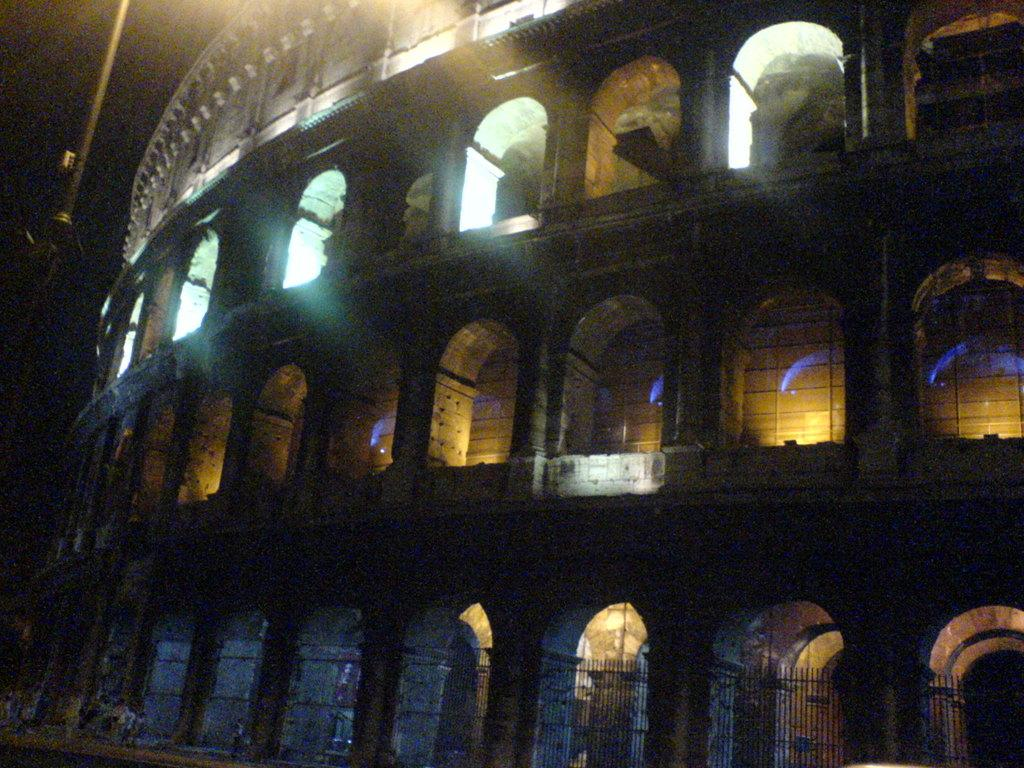What type of structure is present in the image? There is a building in the image. What can be seen illuminated in the image? There are lights visible in the image. What type of barrier is present in the image? There is a fence in the image. What type of learning is taking place in the image? There is no indication of learning or any educational activity in the image. 